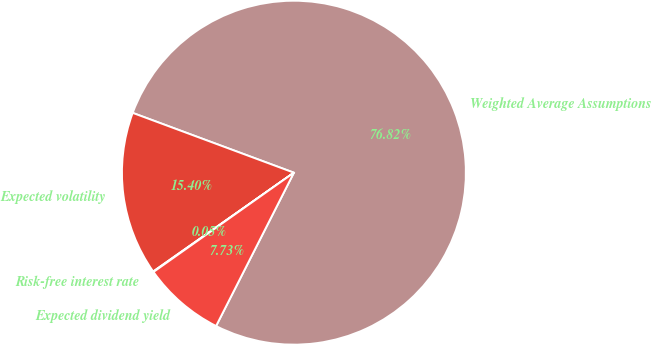Convert chart. <chart><loc_0><loc_0><loc_500><loc_500><pie_chart><fcel>Weighted Average Assumptions<fcel>Expected volatility<fcel>Risk-free interest rate<fcel>Expected dividend yield<nl><fcel>76.82%<fcel>15.4%<fcel>0.05%<fcel>7.73%<nl></chart> 